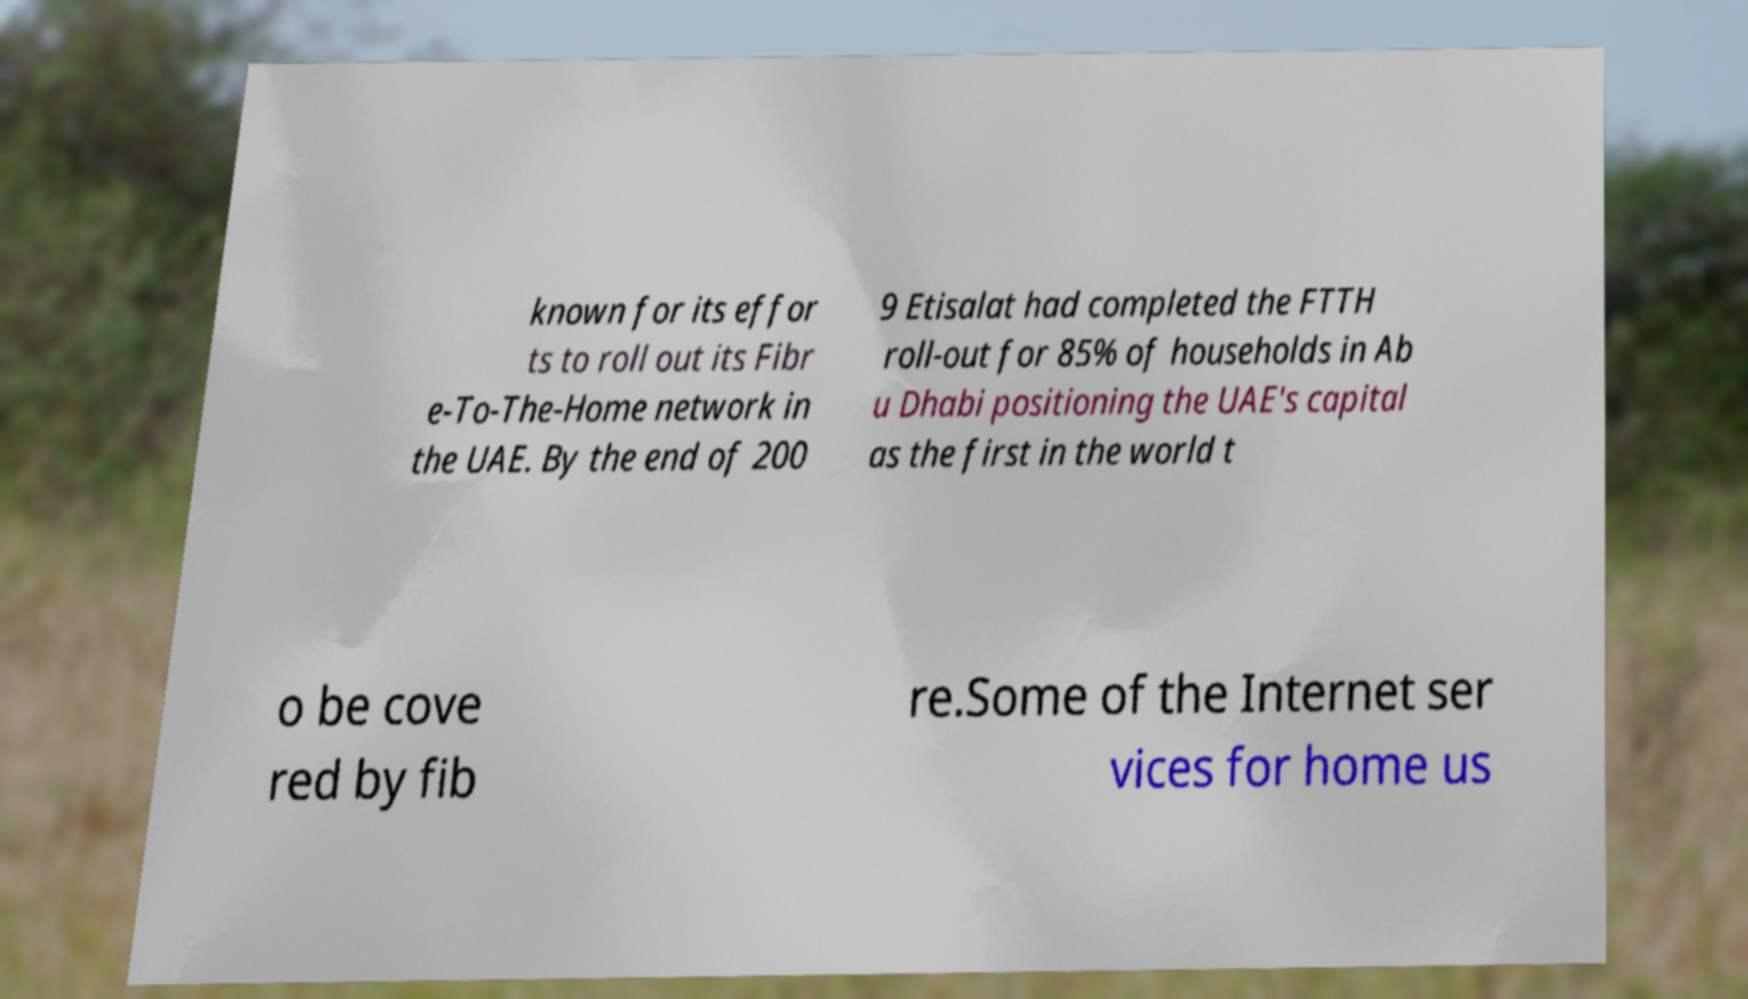There's text embedded in this image that I need extracted. Can you transcribe it verbatim? known for its effor ts to roll out its Fibr e-To-The-Home network in the UAE. By the end of 200 9 Etisalat had completed the FTTH roll-out for 85% of households in Ab u Dhabi positioning the UAE's capital as the first in the world t o be cove red by fib re.Some of the Internet ser vices for home us 